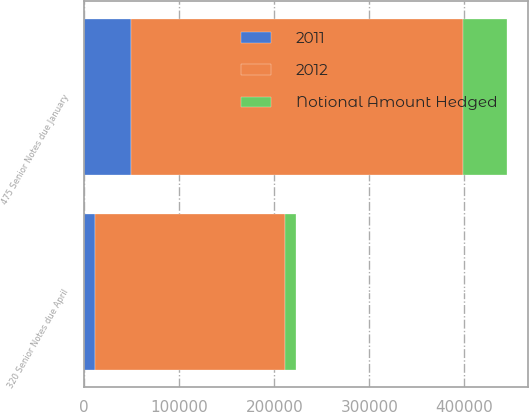Convert chart to OTSL. <chart><loc_0><loc_0><loc_500><loc_500><stacked_bar_chart><ecel><fcel>320 Senior Notes due April<fcel>475 Senior Notes due January<nl><fcel>2012<fcel>200000<fcel>350000<nl><fcel>2011<fcel>11659<fcel>48912<nl><fcel>Notional Amount Hedged<fcel>10858<fcel>45662<nl></chart> 